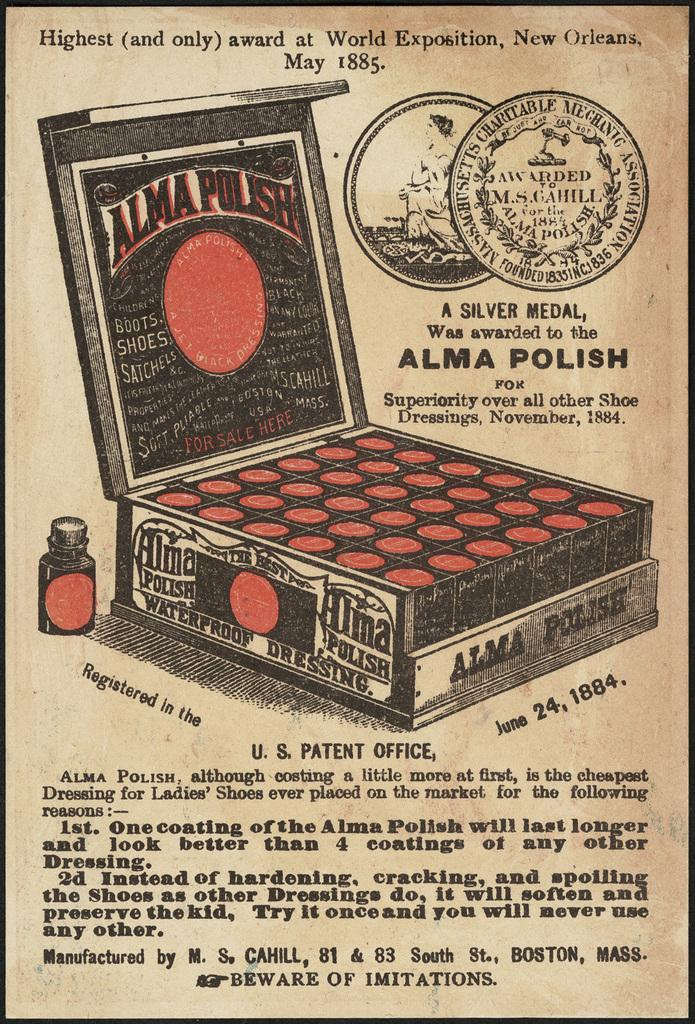<image>
Relay a brief, clear account of the picture shown. An old ad for Alma polish manufactured in Boston. 